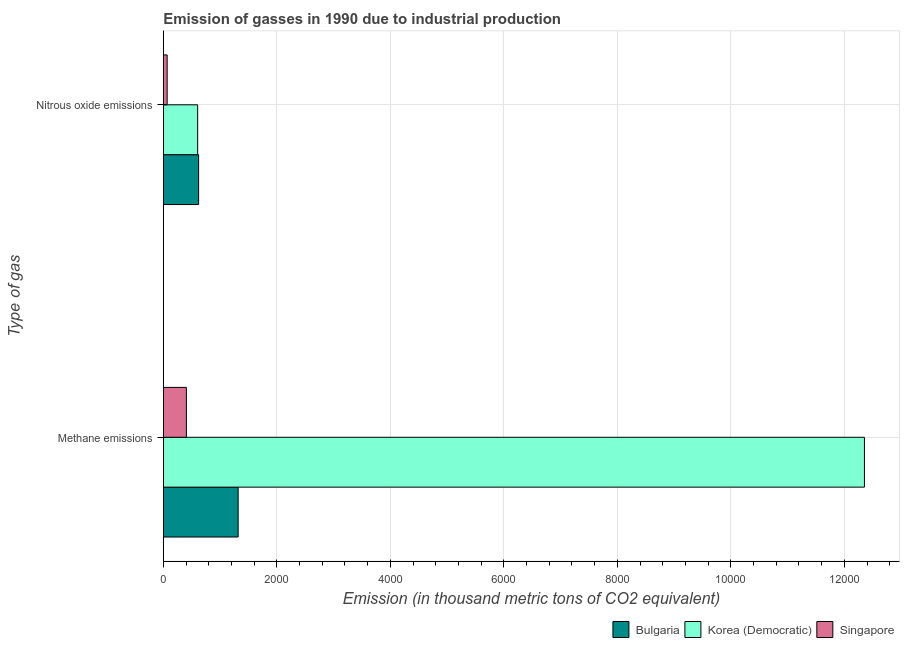Are the number of bars per tick equal to the number of legend labels?
Offer a very short reply. Yes. Are the number of bars on each tick of the Y-axis equal?
Offer a terse response. Yes. What is the label of the 2nd group of bars from the top?
Keep it short and to the point. Methane emissions. What is the amount of methane emissions in Singapore?
Ensure brevity in your answer.  406.8. Across all countries, what is the maximum amount of methane emissions?
Your response must be concise. 1.24e+04. Across all countries, what is the minimum amount of nitrous oxide emissions?
Your answer should be compact. 67.9. In which country was the amount of methane emissions minimum?
Give a very brief answer. Singapore. What is the total amount of nitrous oxide emissions in the graph?
Keep it short and to the point. 1295.5. What is the difference between the amount of nitrous oxide emissions in Bulgaria and that in Singapore?
Your answer should be very brief. 554.1. What is the difference between the amount of methane emissions in Singapore and the amount of nitrous oxide emissions in Bulgaria?
Keep it short and to the point. -215.2. What is the average amount of methane emissions per country?
Provide a succinct answer. 4693.03. What is the difference between the amount of nitrous oxide emissions and amount of methane emissions in Singapore?
Keep it short and to the point. -338.9. In how many countries, is the amount of nitrous oxide emissions greater than 11200 thousand metric tons?
Make the answer very short. 0. What is the ratio of the amount of methane emissions in Singapore to that in Bulgaria?
Your answer should be compact. 0.31. In how many countries, is the amount of methane emissions greater than the average amount of methane emissions taken over all countries?
Offer a very short reply. 1. What does the 3rd bar from the top in Methane emissions represents?
Your response must be concise. Bulgaria. What does the 1st bar from the bottom in Methane emissions represents?
Ensure brevity in your answer.  Bulgaria. How many bars are there?
Make the answer very short. 6. Are all the bars in the graph horizontal?
Offer a terse response. Yes. Does the graph contain any zero values?
Your response must be concise. No. Does the graph contain grids?
Your answer should be compact. Yes. Where does the legend appear in the graph?
Your answer should be compact. Bottom right. How many legend labels are there?
Your answer should be compact. 3. What is the title of the graph?
Your answer should be compact. Emission of gasses in 1990 due to industrial production. What is the label or title of the X-axis?
Make the answer very short. Emission (in thousand metric tons of CO2 equivalent). What is the label or title of the Y-axis?
Provide a short and direct response. Type of gas. What is the Emission (in thousand metric tons of CO2 equivalent) in Bulgaria in Methane emissions?
Offer a very short reply. 1318.6. What is the Emission (in thousand metric tons of CO2 equivalent) in Korea (Democratic) in Methane emissions?
Give a very brief answer. 1.24e+04. What is the Emission (in thousand metric tons of CO2 equivalent) in Singapore in Methane emissions?
Your answer should be compact. 406.8. What is the Emission (in thousand metric tons of CO2 equivalent) in Bulgaria in Nitrous oxide emissions?
Offer a terse response. 622. What is the Emission (in thousand metric tons of CO2 equivalent) of Korea (Democratic) in Nitrous oxide emissions?
Make the answer very short. 605.6. What is the Emission (in thousand metric tons of CO2 equivalent) in Singapore in Nitrous oxide emissions?
Your answer should be very brief. 67.9. Across all Type of gas, what is the maximum Emission (in thousand metric tons of CO2 equivalent) in Bulgaria?
Ensure brevity in your answer.  1318.6. Across all Type of gas, what is the maximum Emission (in thousand metric tons of CO2 equivalent) in Korea (Democratic)?
Your answer should be compact. 1.24e+04. Across all Type of gas, what is the maximum Emission (in thousand metric tons of CO2 equivalent) of Singapore?
Your answer should be compact. 406.8. Across all Type of gas, what is the minimum Emission (in thousand metric tons of CO2 equivalent) of Bulgaria?
Offer a terse response. 622. Across all Type of gas, what is the minimum Emission (in thousand metric tons of CO2 equivalent) of Korea (Democratic)?
Give a very brief answer. 605.6. Across all Type of gas, what is the minimum Emission (in thousand metric tons of CO2 equivalent) in Singapore?
Your answer should be compact. 67.9. What is the total Emission (in thousand metric tons of CO2 equivalent) of Bulgaria in the graph?
Provide a succinct answer. 1940.6. What is the total Emission (in thousand metric tons of CO2 equivalent) in Korea (Democratic) in the graph?
Give a very brief answer. 1.30e+04. What is the total Emission (in thousand metric tons of CO2 equivalent) of Singapore in the graph?
Give a very brief answer. 474.7. What is the difference between the Emission (in thousand metric tons of CO2 equivalent) of Bulgaria in Methane emissions and that in Nitrous oxide emissions?
Provide a short and direct response. 696.6. What is the difference between the Emission (in thousand metric tons of CO2 equivalent) of Korea (Democratic) in Methane emissions and that in Nitrous oxide emissions?
Offer a terse response. 1.17e+04. What is the difference between the Emission (in thousand metric tons of CO2 equivalent) of Singapore in Methane emissions and that in Nitrous oxide emissions?
Give a very brief answer. 338.9. What is the difference between the Emission (in thousand metric tons of CO2 equivalent) of Bulgaria in Methane emissions and the Emission (in thousand metric tons of CO2 equivalent) of Korea (Democratic) in Nitrous oxide emissions?
Provide a short and direct response. 713. What is the difference between the Emission (in thousand metric tons of CO2 equivalent) in Bulgaria in Methane emissions and the Emission (in thousand metric tons of CO2 equivalent) in Singapore in Nitrous oxide emissions?
Make the answer very short. 1250.7. What is the difference between the Emission (in thousand metric tons of CO2 equivalent) in Korea (Democratic) in Methane emissions and the Emission (in thousand metric tons of CO2 equivalent) in Singapore in Nitrous oxide emissions?
Offer a very short reply. 1.23e+04. What is the average Emission (in thousand metric tons of CO2 equivalent) in Bulgaria per Type of gas?
Your response must be concise. 970.3. What is the average Emission (in thousand metric tons of CO2 equivalent) in Korea (Democratic) per Type of gas?
Your response must be concise. 6479.65. What is the average Emission (in thousand metric tons of CO2 equivalent) in Singapore per Type of gas?
Your response must be concise. 237.35. What is the difference between the Emission (in thousand metric tons of CO2 equivalent) of Bulgaria and Emission (in thousand metric tons of CO2 equivalent) of Korea (Democratic) in Methane emissions?
Ensure brevity in your answer.  -1.10e+04. What is the difference between the Emission (in thousand metric tons of CO2 equivalent) in Bulgaria and Emission (in thousand metric tons of CO2 equivalent) in Singapore in Methane emissions?
Provide a short and direct response. 911.8. What is the difference between the Emission (in thousand metric tons of CO2 equivalent) in Korea (Democratic) and Emission (in thousand metric tons of CO2 equivalent) in Singapore in Methane emissions?
Ensure brevity in your answer.  1.19e+04. What is the difference between the Emission (in thousand metric tons of CO2 equivalent) in Bulgaria and Emission (in thousand metric tons of CO2 equivalent) in Singapore in Nitrous oxide emissions?
Provide a succinct answer. 554.1. What is the difference between the Emission (in thousand metric tons of CO2 equivalent) in Korea (Democratic) and Emission (in thousand metric tons of CO2 equivalent) in Singapore in Nitrous oxide emissions?
Make the answer very short. 537.7. What is the ratio of the Emission (in thousand metric tons of CO2 equivalent) in Bulgaria in Methane emissions to that in Nitrous oxide emissions?
Offer a very short reply. 2.12. What is the ratio of the Emission (in thousand metric tons of CO2 equivalent) of Korea (Democratic) in Methane emissions to that in Nitrous oxide emissions?
Your answer should be compact. 20.4. What is the ratio of the Emission (in thousand metric tons of CO2 equivalent) of Singapore in Methane emissions to that in Nitrous oxide emissions?
Provide a succinct answer. 5.99. What is the difference between the highest and the second highest Emission (in thousand metric tons of CO2 equivalent) of Bulgaria?
Make the answer very short. 696.6. What is the difference between the highest and the second highest Emission (in thousand metric tons of CO2 equivalent) in Korea (Democratic)?
Ensure brevity in your answer.  1.17e+04. What is the difference between the highest and the second highest Emission (in thousand metric tons of CO2 equivalent) in Singapore?
Your answer should be compact. 338.9. What is the difference between the highest and the lowest Emission (in thousand metric tons of CO2 equivalent) of Bulgaria?
Keep it short and to the point. 696.6. What is the difference between the highest and the lowest Emission (in thousand metric tons of CO2 equivalent) in Korea (Democratic)?
Give a very brief answer. 1.17e+04. What is the difference between the highest and the lowest Emission (in thousand metric tons of CO2 equivalent) of Singapore?
Provide a short and direct response. 338.9. 